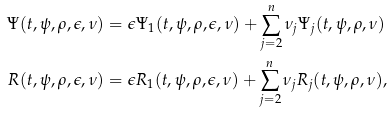Convert formula to latex. <formula><loc_0><loc_0><loc_500><loc_500>\Psi ( t , \psi , \rho , \epsilon , \nu ) & = \epsilon \Psi _ { 1 } ( t , \psi , \rho , \epsilon , \nu ) + \sum _ { j = 2 } ^ { n } \nu _ { j } \Psi _ { j } ( t , \psi , \rho , \nu ) \\ R ( t , \psi , \rho , \epsilon , \nu ) & = \epsilon R _ { 1 } ( t , \psi , \rho , \epsilon , \nu ) + \sum _ { j = 2 } ^ { n } \nu _ { j } R _ { j } ( t , \psi , \rho , \nu ) ,</formula> 